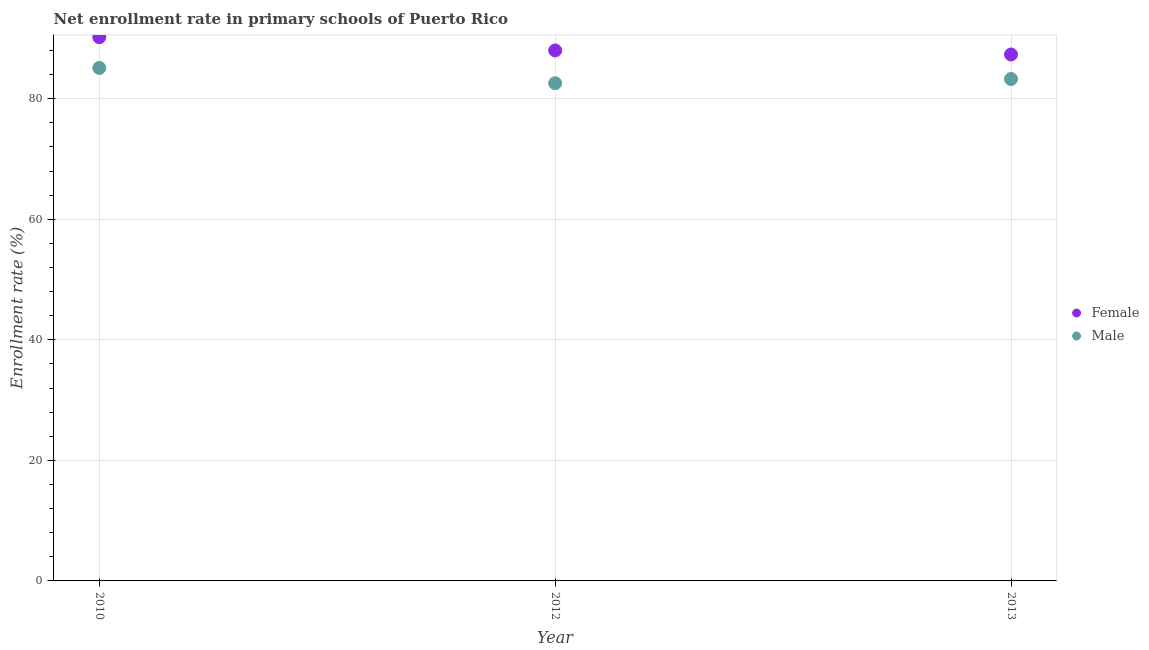Is the number of dotlines equal to the number of legend labels?
Offer a terse response. Yes. What is the enrollment rate of male students in 2010?
Make the answer very short. 85.12. Across all years, what is the maximum enrollment rate of male students?
Provide a short and direct response. 85.12. Across all years, what is the minimum enrollment rate of female students?
Give a very brief answer. 87.35. In which year was the enrollment rate of male students maximum?
Your answer should be compact. 2010. What is the total enrollment rate of male students in the graph?
Provide a short and direct response. 250.99. What is the difference between the enrollment rate of female students in 2010 and that in 2013?
Your answer should be very brief. 2.87. What is the difference between the enrollment rate of male students in 2012 and the enrollment rate of female students in 2013?
Provide a short and direct response. -4.77. What is the average enrollment rate of female students per year?
Offer a terse response. 88.53. In the year 2013, what is the difference between the enrollment rate of male students and enrollment rate of female students?
Your answer should be compact. -4.06. What is the ratio of the enrollment rate of female students in 2012 to that in 2013?
Your answer should be very brief. 1.01. Is the enrollment rate of female students in 2012 less than that in 2013?
Your response must be concise. No. What is the difference between the highest and the second highest enrollment rate of male students?
Provide a short and direct response. 1.84. What is the difference between the highest and the lowest enrollment rate of male students?
Your answer should be very brief. 2.54. Is the sum of the enrollment rate of female students in 2010 and 2012 greater than the maximum enrollment rate of male students across all years?
Offer a terse response. Yes. Does the enrollment rate of female students monotonically increase over the years?
Give a very brief answer. No. Is the enrollment rate of male students strictly less than the enrollment rate of female students over the years?
Ensure brevity in your answer.  Yes. How many dotlines are there?
Keep it short and to the point. 2. How many years are there in the graph?
Make the answer very short. 3. What is the difference between two consecutive major ticks on the Y-axis?
Make the answer very short. 20. Are the values on the major ticks of Y-axis written in scientific E-notation?
Your answer should be compact. No. Where does the legend appear in the graph?
Your answer should be very brief. Center right. What is the title of the graph?
Offer a terse response. Net enrollment rate in primary schools of Puerto Rico. What is the label or title of the Y-axis?
Make the answer very short. Enrollment rate (%). What is the Enrollment rate (%) of Female in 2010?
Provide a succinct answer. 90.22. What is the Enrollment rate (%) of Male in 2010?
Make the answer very short. 85.12. What is the Enrollment rate (%) of Female in 2012?
Your answer should be compact. 88.02. What is the Enrollment rate (%) in Male in 2012?
Ensure brevity in your answer.  82.58. What is the Enrollment rate (%) of Female in 2013?
Provide a succinct answer. 87.35. What is the Enrollment rate (%) of Male in 2013?
Give a very brief answer. 83.29. Across all years, what is the maximum Enrollment rate (%) of Female?
Give a very brief answer. 90.22. Across all years, what is the maximum Enrollment rate (%) of Male?
Your answer should be very brief. 85.12. Across all years, what is the minimum Enrollment rate (%) in Female?
Provide a succinct answer. 87.35. Across all years, what is the minimum Enrollment rate (%) of Male?
Your answer should be compact. 82.58. What is the total Enrollment rate (%) of Female in the graph?
Offer a terse response. 265.59. What is the total Enrollment rate (%) in Male in the graph?
Give a very brief answer. 250.99. What is the difference between the Enrollment rate (%) of Female in 2010 and that in 2012?
Offer a terse response. 2.2. What is the difference between the Enrollment rate (%) of Male in 2010 and that in 2012?
Your response must be concise. 2.54. What is the difference between the Enrollment rate (%) in Female in 2010 and that in 2013?
Give a very brief answer. 2.87. What is the difference between the Enrollment rate (%) of Male in 2010 and that in 2013?
Ensure brevity in your answer.  1.84. What is the difference between the Enrollment rate (%) of Female in 2012 and that in 2013?
Provide a succinct answer. 0.67. What is the difference between the Enrollment rate (%) of Male in 2012 and that in 2013?
Make the answer very short. -0.7. What is the difference between the Enrollment rate (%) in Female in 2010 and the Enrollment rate (%) in Male in 2012?
Your response must be concise. 7.64. What is the difference between the Enrollment rate (%) in Female in 2010 and the Enrollment rate (%) in Male in 2013?
Your answer should be very brief. 6.94. What is the difference between the Enrollment rate (%) of Female in 2012 and the Enrollment rate (%) of Male in 2013?
Keep it short and to the point. 4.74. What is the average Enrollment rate (%) of Female per year?
Make the answer very short. 88.53. What is the average Enrollment rate (%) of Male per year?
Offer a terse response. 83.66. In the year 2010, what is the difference between the Enrollment rate (%) in Female and Enrollment rate (%) in Male?
Make the answer very short. 5.1. In the year 2012, what is the difference between the Enrollment rate (%) in Female and Enrollment rate (%) in Male?
Your answer should be very brief. 5.44. In the year 2013, what is the difference between the Enrollment rate (%) in Female and Enrollment rate (%) in Male?
Provide a short and direct response. 4.06. What is the ratio of the Enrollment rate (%) of Female in 2010 to that in 2012?
Give a very brief answer. 1.02. What is the ratio of the Enrollment rate (%) in Male in 2010 to that in 2012?
Provide a succinct answer. 1.03. What is the ratio of the Enrollment rate (%) in Female in 2010 to that in 2013?
Make the answer very short. 1.03. What is the ratio of the Enrollment rate (%) of Female in 2012 to that in 2013?
Offer a very short reply. 1.01. What is the ratio of the Enrollment rate (%) of Male in 2012 to that in 2013?
Offer a terse response. 0.99. What is the difference between the highest and the second highest Enrollment rate (%) of Female?
Your response must be concise. 2.2. What is the difference between the highest and the second highest Enrollment rate (%) of Male?
Your answer should be very brief. 1.84. What is the difference between the highest and the lowest Enrollment rate (%) in Female?
Give a very brief answer. 2.87. What is the difference between the highest and the lowest Enrollment rate (%) of Male?
Keep it short and to the point. 2.54. 